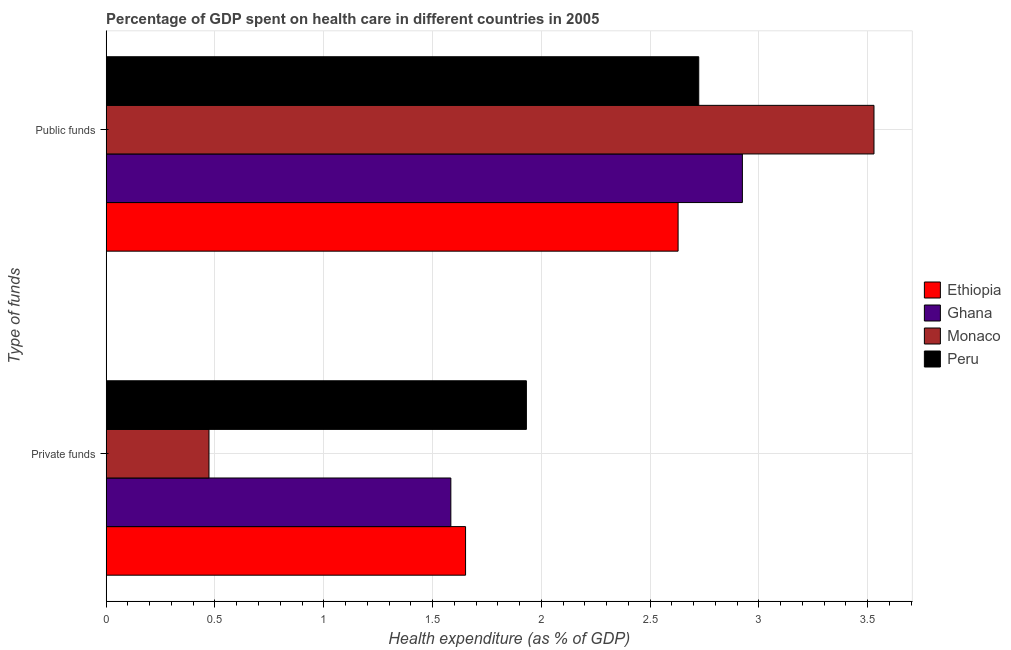How many different coloured bars are there?
Ensure brevity in your answer.  4. Are the number of bars on each tick of the Y-axis equal?
Provide a short and direct response. Yes. How many bars are there on the 1st tick from the top?
Offer a very short reply. 4. What is the label of the 1st group of bars from the top?
Provide a succinct answer. Public funds. What is the amount of public funds spent in healthcare in Monaco?
Your response must be concise. 3.53. Across all countries, what is the maximum amount of public funds spent in healthcare?
Keep it short and to the point. 3.53. Across all countries, what is the minimum amount of public funds spent in healthcare?
Ensure brevity in your answer.  2.63. In which country was the amount of private funds spent in healthcare minimum?
Your answer should be compact. Monaco. What is the total amount of private funds spent in healthcare in the graph?
Make the answer very short. 5.64. What is the difference between the amount of private funds spent in healthcare in Ethiopia and that in Monaco?
Offer a terse response. 1.18. What is the difference between the amount of private funds spent in healthcare in Ghana and the amount of public funds spent in healthcare in Ethiopia?
Make the answer very short. -1.04. What is the average amount of public funds spent in healthcare per country?
Provide a succinct answer. 2.95. What is the difference between the amount of private funds spent in healthcare and amount of public funds spent in healthcare in Ethiopia?
Keep it short and to the point. -0.98. In how many countries, is the amount of private funds spent in healthcare greater than 3 %?
Give a very brief answer. 0. What is the ratio of the amount of public funds spent in healthcare in Monaco to that in Peru?
Offer a very short reply. 1.3. Is the amount of public funds spent in healthcare in Monaco less than that in Ethiopia?
Your response must be concise. No. What does the 2nd bar from the top in Public funds represents?
Make the answer very short. Monaco. What does the 2nd bar from the bottom in Private funds represents?
Provide a short and direct response. Ghana. Are all the bars in the graph horizontal?
Keep it short and to the point. Yes. What is the difference between two consecutive major ticks on the X-axis?
Give a very brief answer. 0.5. Does the graph contain any zero values?
Give a very brief answer. No. What is the title of the graph?
Your answer should be very brief. Percentage of GDP spent on health care in different countries in 2005. What is the label or title of the X-axis?
Offer a very short reply. Health expenditure (as % of GDP). What is the label or title of the Y-axis?
Your response must be concise. Type of funds. What is the Health expenditure (as % of GDP) in Ethiopia in Private funds?
Your answer should be compact. 1.65. What is the Health expenditure (as % of GDP) in Ghana in Private funds?
Provide a succinct answer. 1.58. What is the Health expenditure (as % of GDP) of Monaco in Private funds?
Your response must be concise. 0.47. What is the Health expenditure (as % of GDP) of Peru in Private funds?
Give a very brief answer. 1.93. What is the Health expenditure (as % of GDP) of Ethiopia in Public funds?
Your response must be concise. 2.63. What is the Health expenditure (as % of GDP) of Ghana in Public funds?
Offer a terse response. 2.92. What is the Health expenditure (as % of GDP) of Monaco in Public funds?
Provide a succinct answer. 3.53. What is the Health expenditure (as % of GDP) of Peru in Public funds?
Your answer should be very brief. 2.72. Across all Type of funds, what is the maximum Health expenditure (as % of GDP) of Ethiopia?
Keep it short and to the point. 2.63. Across all Type of funds, what is the maximum Health expenditure (as % of GDP) of Ghana?
Your answer should be compact. 2.92. Across all Type of funds, what is the maximum Health expenditure (as % of GDP) in Monaco?
Keep it short and to the point. 3.53. Across all Type of funds, what is the maximum Health expenditure (as % of GDP) of Peru?
Your answer should be compact. 2.72. Across all Type of funds, what is the minimum Health expenditure (as % of GDP) of Ethiopia?
Your response must be concise. 1.65. Across all Type of funds, what is the minimum Health expenditure (as % of GDP) in Ghana?
Your answer should be compact. 1.58. Across all Type of funds, what is the minimum Health expenditure (as % of GDP) in Monaco?
Offer a very short reply. 0.47. Across all Type of funds, what is the minimum Health expenditure (as % of GDP) in Peru?
Ensure brevity in your answer.  1.93. What is the total Health expenditure (as % of GDP) in Ethiopia in the graph?
Your response must be concise. 4.28. What is the total Health expenditure (as % of GDP) in Ghana in the graph?
Provide a succinct answer. 4.51. What is the total Health expenditure (as % of GDP) of Monaco in the graph?
Keep it short and to the point. 4. What is the total Health expenditure (as % of GDP) of Peru in the graph?
Keep it short and to the point. 4.65. What is the difference between the Health expenditure (as % of GDP) in Ethiopia in Private funds and that in Public funds?
Your response must be concise. -0.98. What is the difference between the Health expenditure (as % of GDP) in Ghana in Private funds and that in Public funds?
Ensure brevity in your answer.  -1.34. What is the difference between the Health expenditure (as % of GDP) in Monaco in Private funds and that in Public funds?
Offer a terse response. -3.06. What is the difference between the Health expenditure (as % of GDP) in Peru in Private funds and that in Public funds?
Ensure brevity in your answer.  -0.79. What is the difference between the Health expenditure (as % of GDP) of Ethiopia in Private funds and the Health expenditure (as % of GDP) of Ghana in Public funds?
Your answer should be very brief. -1.27. What is the difference between the Health expenditure (as % of GDP) of Ethiopia in Private funds and the Health expenditure (as % of GDP) of Monaco in Public funds?
Keep it short and to the point. -1.88. What is the difference between the Health expenditure (as % of GDP) in Ethiopia in Private funds and the Health expenditure (as % of GDP) in Peru in Public funds?
Provide a short and direct response. -1.07. What is the difference between the Health expenditure (as % of GDP) in Ghana in Private funds and the Health expenditure (as % of GDP) in Monaco in Public funds?
Offer a terse response. -1.94. What is the difference between the Health expenditure (as % of GDP) in Ghana in Private funds and the Health expenditure (as % of GDP) in Peru in Public funds?
Provide a succinct answer. -1.14. What is the difference between the Health expenditure (as % of GDP) of Monaco in Private funds and the Health expenditure (as % of GDP) of Peru in Public funds?
Provide a short and direct response. -2.25. What is the average Health expenditure (as % of GDP) in Ethiopia per Type of funds?
Your response must be concise. 2.14. What is the average Health expenditure (as % of GDP) in Ghana per Type of funds?
Provide a short and direct response. 2.25. What is the average Health expenditure (as % of GDP) in Monaco per Type of funds?
Make the answer very short. 2. What is the average Health expenditure (as % of GDP) of Peru per Type of funds?
Keep it short and to the point. 2.33. What is the difference between the Health expenditure (as % of GDP) of Ethiopia and Health expenditure (as % of GDP) of Ghana in Private funds?
Offer a terse response. 0.07. What is the difference between the Health expenditure (as % of GDP) in Ethiopia and Health expenditure (as % of GDP) in Monaco in Private funds?
Your answer should be very brief. 1.18. What is the difference between the Health expenditure (as % of GDP) in Ethiopia and Health expenditure (as % of GDP) in Peru in Private funds?
Offer a terse response. -0.28. What is the difference between the Health expenditure (as % of GDP) of Ghana and Health expenditure (as % of GDP) of Monaco in Private funds?
Give a very brief answer. 1.11. What is the difference between the Health expenditure (as % of GDP) of Ghana and Health expenditure (as % of GDP) of Peru in Private funds?
Make the answer very short. -0.35. What is the difference between the Health expenditure (as % of GDP) of Monaco and Health expenditure (as % of GDP) of Peru in Private funds?
Provide a short and direct response. -1.46. What is the difference between the Health expenditure (as % of GDP) in Ethiopia and Health expenditure (as % of GDP) in Ghana in Public funds?
Offer a very short reply. -0.3. What is the difference between the Health expenditure (as % of GDP) in Ethiopia and Health expenditure (as % of GDP) in Monaco in Public funds?
Give a very brief answer. -0.9. What is the difference between the Health expenditure (as % of GDP) in Ethiopia and Health expenditure (as % of GDP) in Peru in Public funds?
Your answer should be very brief. -0.1. What is the difference between the Health expenditure (as % of GDP) in Ghana and Health expenditure (as % of GDP) in Monaco in Public funds?
Offer a very short reply. -0.6. What is the difference between the Health expenditure (as % of GDP) of Ghana and Health expenditure (as % of GDP) of Peru in Public funds?
Give a very brief answer. 0.2. What is the difference between the Health expenditure (as % of GDP) in Monaco and Health expenditure (as % of GDP) in Peru in Public funds?
Ensure brevity in your answer.  0.81. What is the ratio of the Health expenditure (as % of GDP) of Ethiopia in Private funds to that in Public funds?
Offer a terse response. 0.63. What is the ratio of the Health expenditure (as % of GDP) in Ghana in Private funds to that in Public funds?
Your answer should be very brief. 0.54. What is the ratio of the Health expenditure (as % of GDP) in Monaco in Private funds to that in Public funds?
Offer a very short reply. 0.13. What is the ratio of the Health expenditure (as % of GDP) in Peru in Private funds to that in Public funds?
Your answer should be compact. 0.71. What is the difference between the highest and the second highest Health expenditure (as % of GDP) of Ethiopia?
Your response must be concise. 0.98. What is the difference between the highest and the second highest Health expenditure (as % of GDP) in Ghana?
Offer a terse response. 1.34. What is the difference between the highest and the second highest Health expenditure (as % of GDP) of Monaco?
Your response must be concise. 3.06. What is the difference between the highest and the second highest Health expenditure (as % of GDP) in Peru?
Provide a short and direct response. 0.79. What is the difference between the highest and the lowest Health expenditure (as % of GDP) in Ethiopia?
Offer a very short reply. 0.98. What is the difference between the highest and the lowest Health expenditure (as % of GDP) in Ghana?
Your response must be concise. 1.34. What is the difference between the highest and the lowest Health expenditure (as % of GDP) of Monaco?
Your answer should be very brief. 3.06. What is the difference between the highest and the lowest Health expenditure (as % of GDP) in Peru?
Your response must be concise. 0.79. 